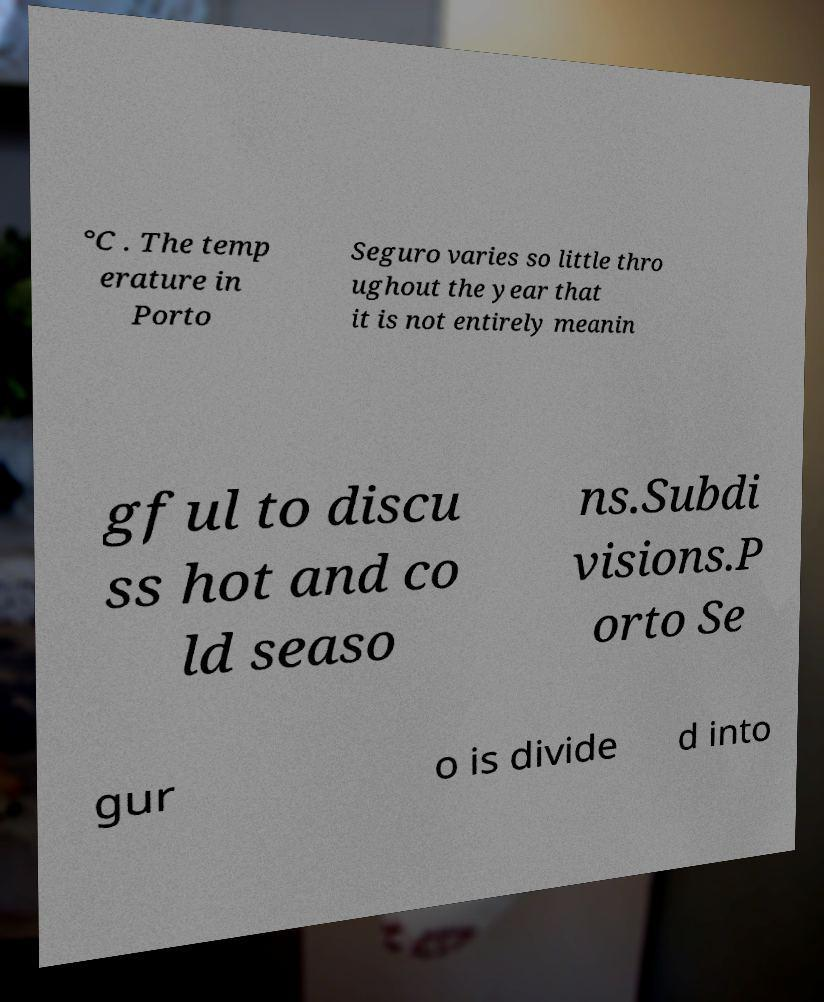Could you assist in decoding the text presented in this image and type it out clearly? °C . The temp erature in Porto Seguro varies so little thro ughout the year that it is not entirely meanin gful to discu ss hot and co ld seaso ns.Subdi visions.P orto Se gur o is divide d into 